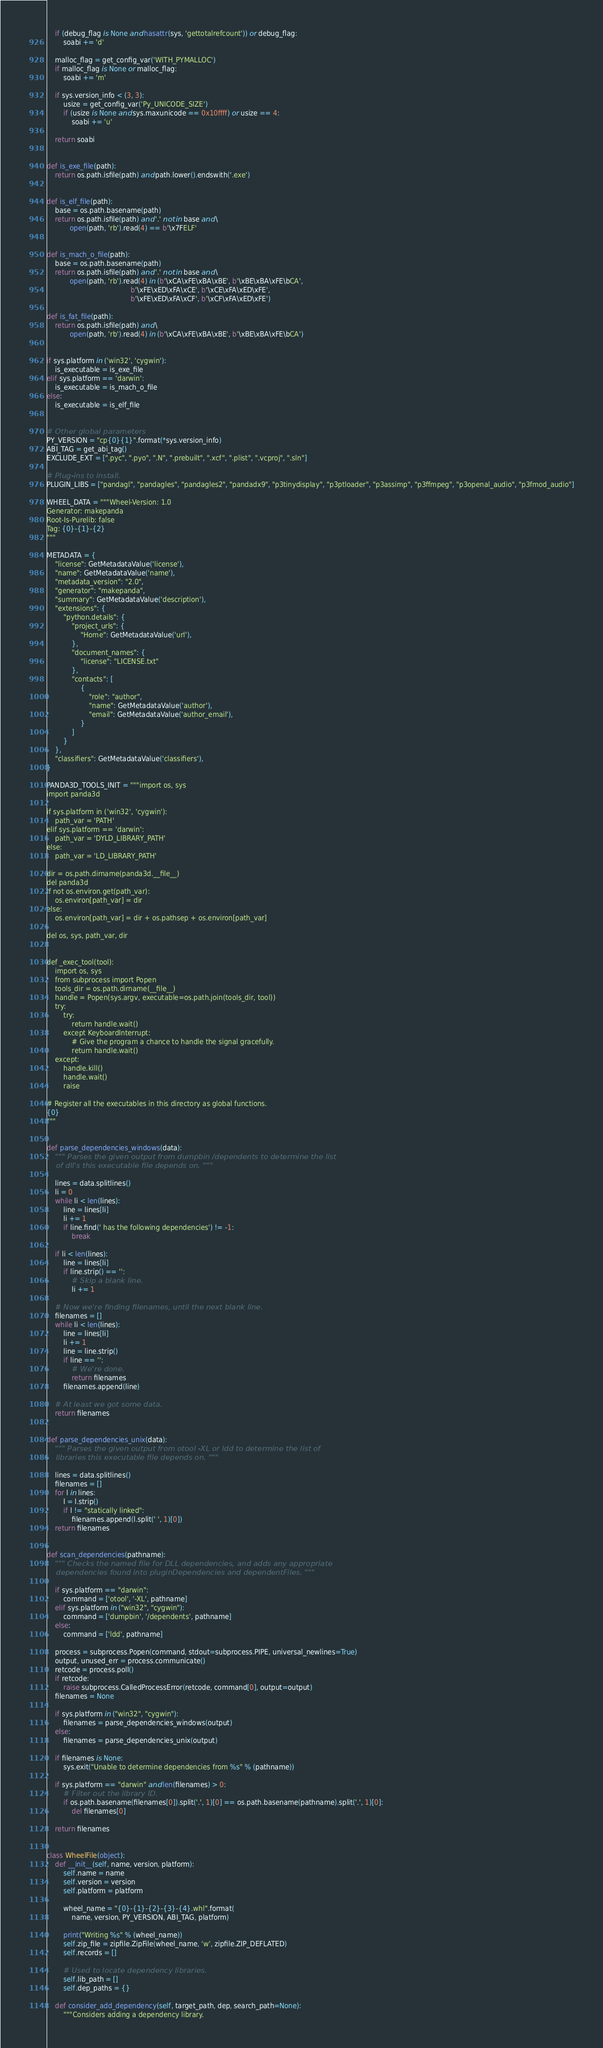Convert code to text. <code><loc_0><loc_0><loc_500><loc_500><_Python_>    if (debug_flag is None and hasattr(sys, 'gettotalrefcount')) or debug_flag:
        soabi += 'd'

    malloc_flag = get_config_var('WITH_PYMALLOC')
    if malloc_flag is None or malloc_flag:
        soabi += 'm'

    if sys.version_info < (3, 3):
        usize = get_config_var('Py_UNICODE_SIZE')
        if (usize is None and sys.maxunicode == 0x10ffff) or usize == 4:
            soabi += 'u'

    return soabi


def is_exe_file(path):
    return os.path.isfile(path) and path.lower().endswith('.exe')


def is_elf_file(path):
    base = os.path.basename(path)
    return os.path.isfile(path) and '.' not in base and \
           open(path, 'rb').read(4) == b'\x7FELF'


def is_mach_o_file(path):
    base = os.path.basename(path)
    return os.path.isfile(path) and '.' not in base and \
           open(path, 'rb').read(4) in (b'\xCA\xFE\xBA\xBE', b'\xBE\xBA\xFE\bCA',
                                        b'\xFE\xED\xFA\xCE', b'\xCE\xFA\xED\xFE',
                                        b'\xFE\xED\xFA\xCF', b'\xCF\xFA\xED\xFE')

def is_fat_file(path):
    return os.path.isfile(path) and \
           open(path, 'rb').read(4) in (b'\xCA\xFE\xBA\xBE', b'\xBE\xBA\xFE\bCA')


if sys.platform in ('win32', 'cygwin'):
    is_executable = is_exe_file
elif sys.platform == 'darwin':
    is_executable = is_mach_o_file
else:
    is_executable = is_elf_file


# Other global parameters
PY_VERSION = "cp{0}{1}".format(*sys.version_info)
ABI_TAG = get_abi_tag()
EXCLUDE_EXT = [".pyc", ".pyo", ".N", ".prebuilt", ".xcf", ".plist", ".vcproj", ".sln"]

# Plug-ins to install.
PLUGIN_LIBS = ["pandagl", "pandagles", "pandagles2", "pandadx9", "p3tinydisplay", "p3ptloader", "p3assimp", "p3ffmpeg", "p3openal_audio", "p3fmod_audio"]

WHEEL_DATA = """Wheel-Version: 1.0
Generator: makepanda
Root-Is-Purelib: false
Tag: {0}-{1}-{2}
"""

METADATA = {
    "license": GetMetadataValue('license'),
    "name": GetMetadataValue('name'),
    "metadata_version": "2.0",
    "generator": "makepanda",
    "summary": GetMetadataValue('description'),
    "extensions": {
        "python.details": {
            "project_urls": {
                "Home": GetMetadataValue('url'),
            },
            "document_names": {
                "license": "LICENSE.txt"
            },
            "contacts": [
                {
                    "role": "author",
                    "name": GetMetadataValue('author'),
                    "email": GetMetadataValue('author_email'),
                }
            ]
        }
    },
    "classifiers": GetMetadataValue('classifiers'),
}

PANDA3D_TOOLS_INIT = """import os, sys
import panda3d

if sys.platform in ('win32', 'cygwin'):
    path_var = 'PATH'
elif sys.platform == 'darwin':
    path_var = 'DYLD_LIBRARY_PATH'
else:
    path_var = 'LD_LIBRARY_PATH'

dir = os.path.dirname(panda3d.__file__)
del panda3d
if not os.environ.get(path_var):
    os.environ[path_var] = dir
else:
    os.environ[path_var] = dir + os.pathsep + os.environ[path_var]

del os, sys, path_var, dir


def _exec_tool(tool):
    import os, sys
    from subprocess import Popen
    tools_dir = os.path.dirname(__file__)
    handle = Popen(sys.argv, executable=os.path.join(tools_dir, tool))
    try:
        try:
            return handle.wait()
        except KeyboardInterrupt:
            # Give the program a chance to handle the signal gracefully.
            return handle.wait()
    except:
        handle.kill()
        handle.wait()
        raise

# Register all the executables in this directory as global functions.
{0}
"""


def parse_dependencies_windows(data):
    """ Parses the given output from dumpbin /dependents to determine the list
    of dll's this executable file depends on. """

    lines = data.splitlines()
    li = 0
    while li < len(lines):
        line = lines[li]
        li += 1
        if line.find(' has the following dependencies') != -1:
            break

    if li < len(lines):
        line = lines[li]
        if line.strip() == '':
            # Skip a blank line.
            li += 1

    # Now we're finding filenames, until the next blank line.
    filenames = []
    while li < len(lines):
        line = lines[li]
        li += 1
        line = line.strip()
        if line == '':
            # We're done.
            return filenames
        filenames.append(line)

    # At least we got some data.
    return filenames


def parse_dependencies_unix(data):
    """ Parses the given output from otool -XL or ldd to determine the list of
    libraries this executable file depends on. """

    lines = data.splitlines()
    filenames = []
    for l in lines:
        l = l.strip()
        if l != "statically linked":
            filenames.append(l.split(' ', 1)[0])
    return filenames


def scan_dependencies(pathname):
    """ Checks the named file for DLL dependencies, and adds any appropriate
    dependencies found into pluginDependencies and dependentFiles. """

    if sys.platform == "darwin":
        command = ['otool', '-XL', pathname]
    elif sys.platform in ("win32", "cygwin"):
        command = ['dumpbin', '/dependents', pathname]
    else:
        command = ['ldd', pathname]

    process = subprocess.Popen(command, stdout=subprocess.PIPE, universal_newlines=True)
    output, unused_err = process.communicate()
    retcode = process.poll()
    if retcode:
        raise subprocess.CalledProcessError(retcode, command[0], output=output)
    filenames = None

    if sys.platform in ("win32", "cygwin"):
        filenames = parse_dependencies_windows(output)
    else:
        filenames = parse_dependencies_unix(output)

    if filenames is None:
        sys.exit("Unable to determine dependencies from %s" % (pathname))

    if sys.platform == "darwin" and len(filenames) > 0:
        # Filter out the library ID.
        if os.path.basename(filenames[0]).split('.', 1)[0] == os.path.basename(pathname).split('.', 1)[0]:
            del filenames[0]

    return filenames


class WheelFile(object):
    def __init__(self, name, version, platform):
        self.name = name
        self.version = version
        self.platform = platform

        wheel_name = "{0}-{1}-{2}-{3}-{4}.whl".format(
            name, version, PY_VERSION, ABI_TAG, platform)

        print("Writing %s" % (wheel_name))
        self.zip_file = zipfile.ZipFile(wheel_name, 'w', zipfile.ZIP_DEFLATED)
        self.records = []

        # Used to locate dependency libraries.
        self.lib_path = []
        self.dep_paths = {}

    def consider_add_dependency(self, target_path, dep, search_path=None):
        """Considers adding a dependency library.</code> 